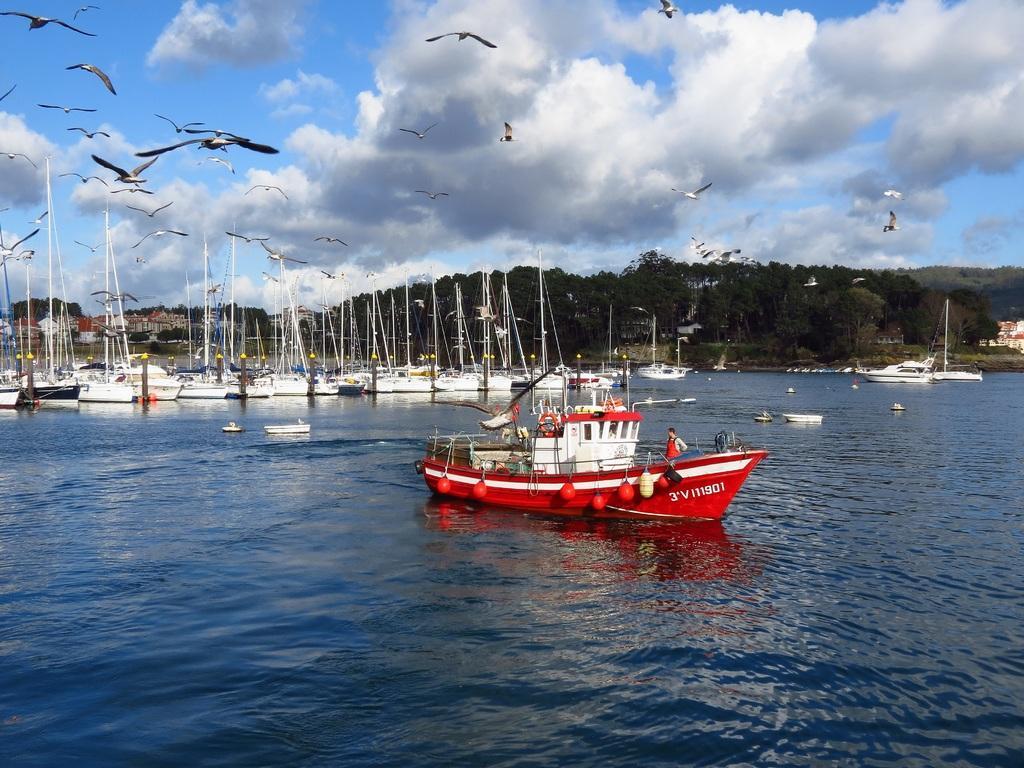Describe this image in one or two sentences. In this picture we can see a group of boats on water and in the background we can see trees,sky,birds flying. 